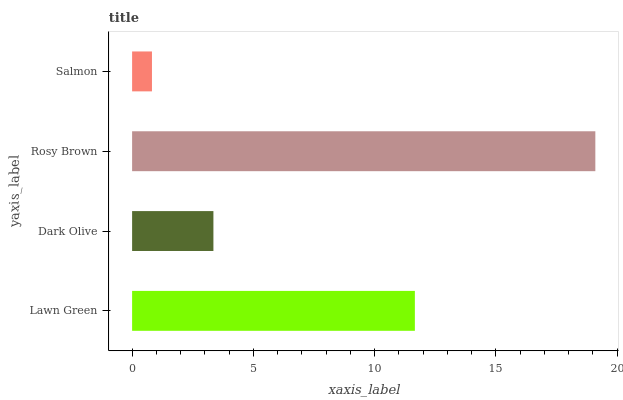Is Salmon the minimum?
Answer yes or no. Yes. Is Rosy Brown the maximum?
Answer yes or no. Yes. Is Dark Olive the minimum?
Answer yes or no. No. Is Dark Olive the maximum?
Answer yes or no. No. Is Lawn Green greater than Dark Olive?
Answer yes or no. Yes. Is Dark Olive less than Lawn Green?
Answer yes or no. Yes. Is Dark Olive greater than Lawn Green?
Answer yes or no. No. Is Lawn Green less than Dark Olive?
Answer yes or no. No. Is Lawn Green the high median?
Answer yes or no. Yes. Is Dark Olive the low median?
Answer yes or no. Yes. Is Dark Olive the high median?
Answer yes or no. No. Is Lawn Green the low median?
Answer yes or no. No. 